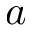Convert formula to latex. <formula><loc_0><loc_0><loc_500><loc_500>a</formula> 